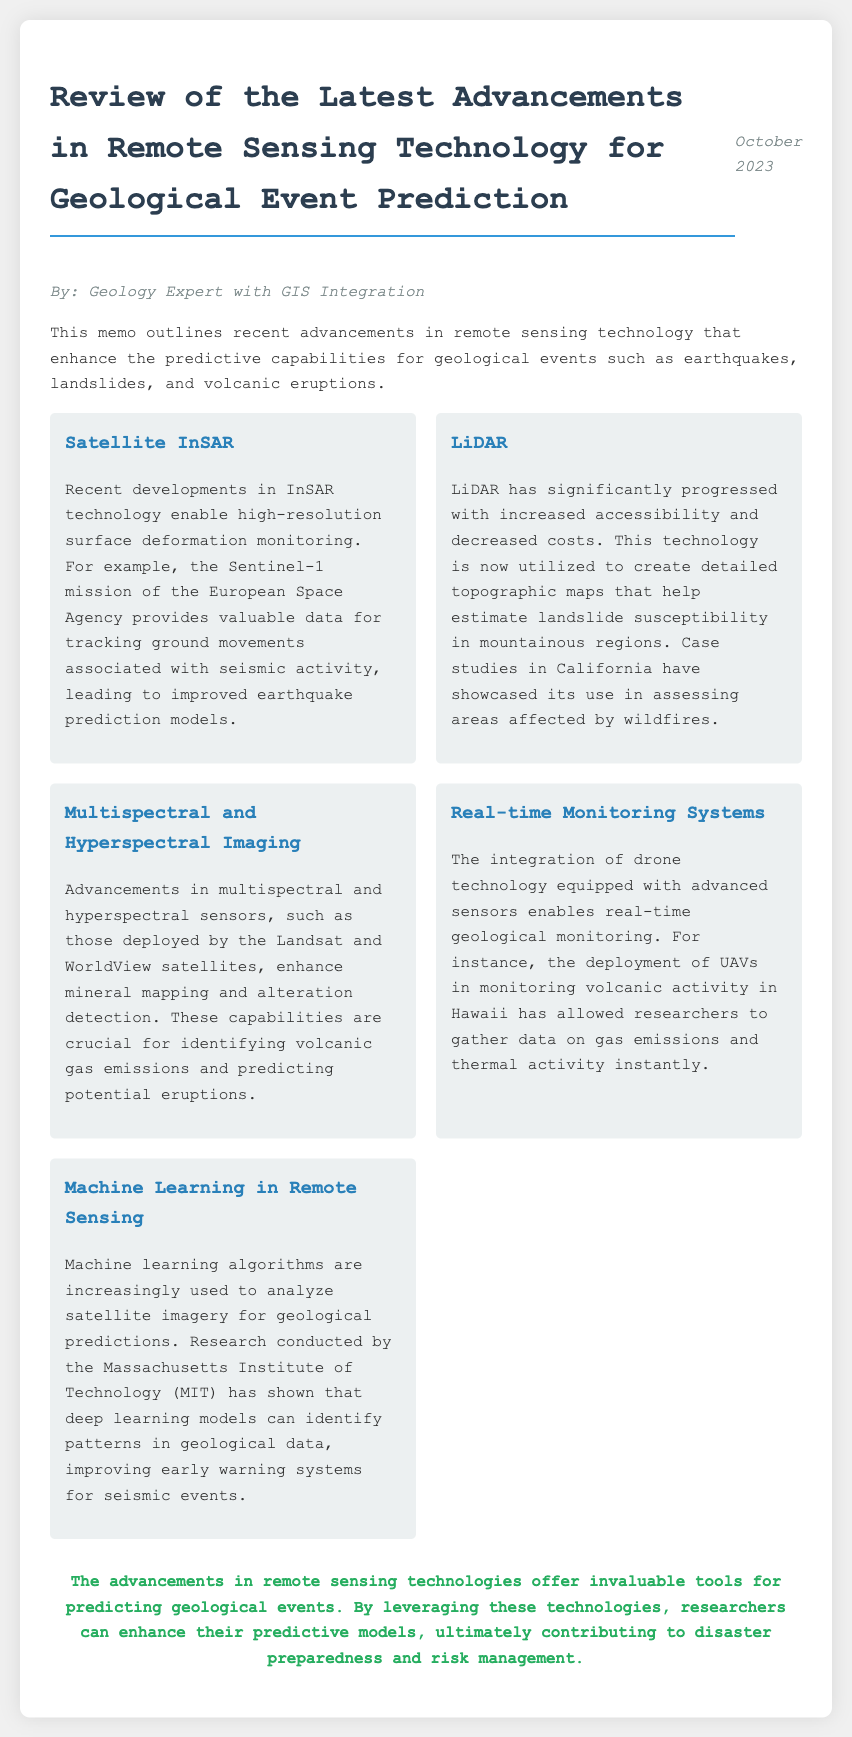What is the title of the memo? The title is explicitly stated at the top of the memo, which conveys the focus on advancements in remote sensing technology for geological event prediction.
Answer: Review of the Latest Advancements in Remote Sensing Technology for Geological Event Prediction Who is the author of the memo? The author is mentioned in the document as the person who has composed the memo, indicating their expertise.
Answer: Geology Expert with GIS Integration What technology does the Sentinel-1 mission utilize? The document specifies that the Sentinel-1 mission employs InSAR technology for monitoring surface deformation related to seismic activity.
Answer: InSAR What has LiDAR technology progressed in? The memo discusses the recent advancements in LiDAR technology regarding its accessibility and cost, which are significant factors for its application.
Answer: Accessibility and decreased costs Which institution conducted research on machine learning algorithms? The memo identifies the Massachusetts Institute of Technology (MIT) as the institution that conducted relevant research on using machine learning for geological predictions.
Answer: Massachusetts Institute of Technology (MIT) What type of imaging has enhanced mineral mapping? The document highlights that advancements in multispectral and hyperspectral imaging are crucial for the identification of specific geological features.
Answer: Multispectral and hyperspectral imaging What does the conclusion emphasize about remote sensing technologies? The final section of the memo summarises the contribution of remote sensing technologies to predictive models, indicating their implications for geological event preparedness.
Answer: Enhancing predictive models What date was the memo published? The date is provided within the document, indicating the timeliness of the information shared in the memo.
Answer: October 2023 